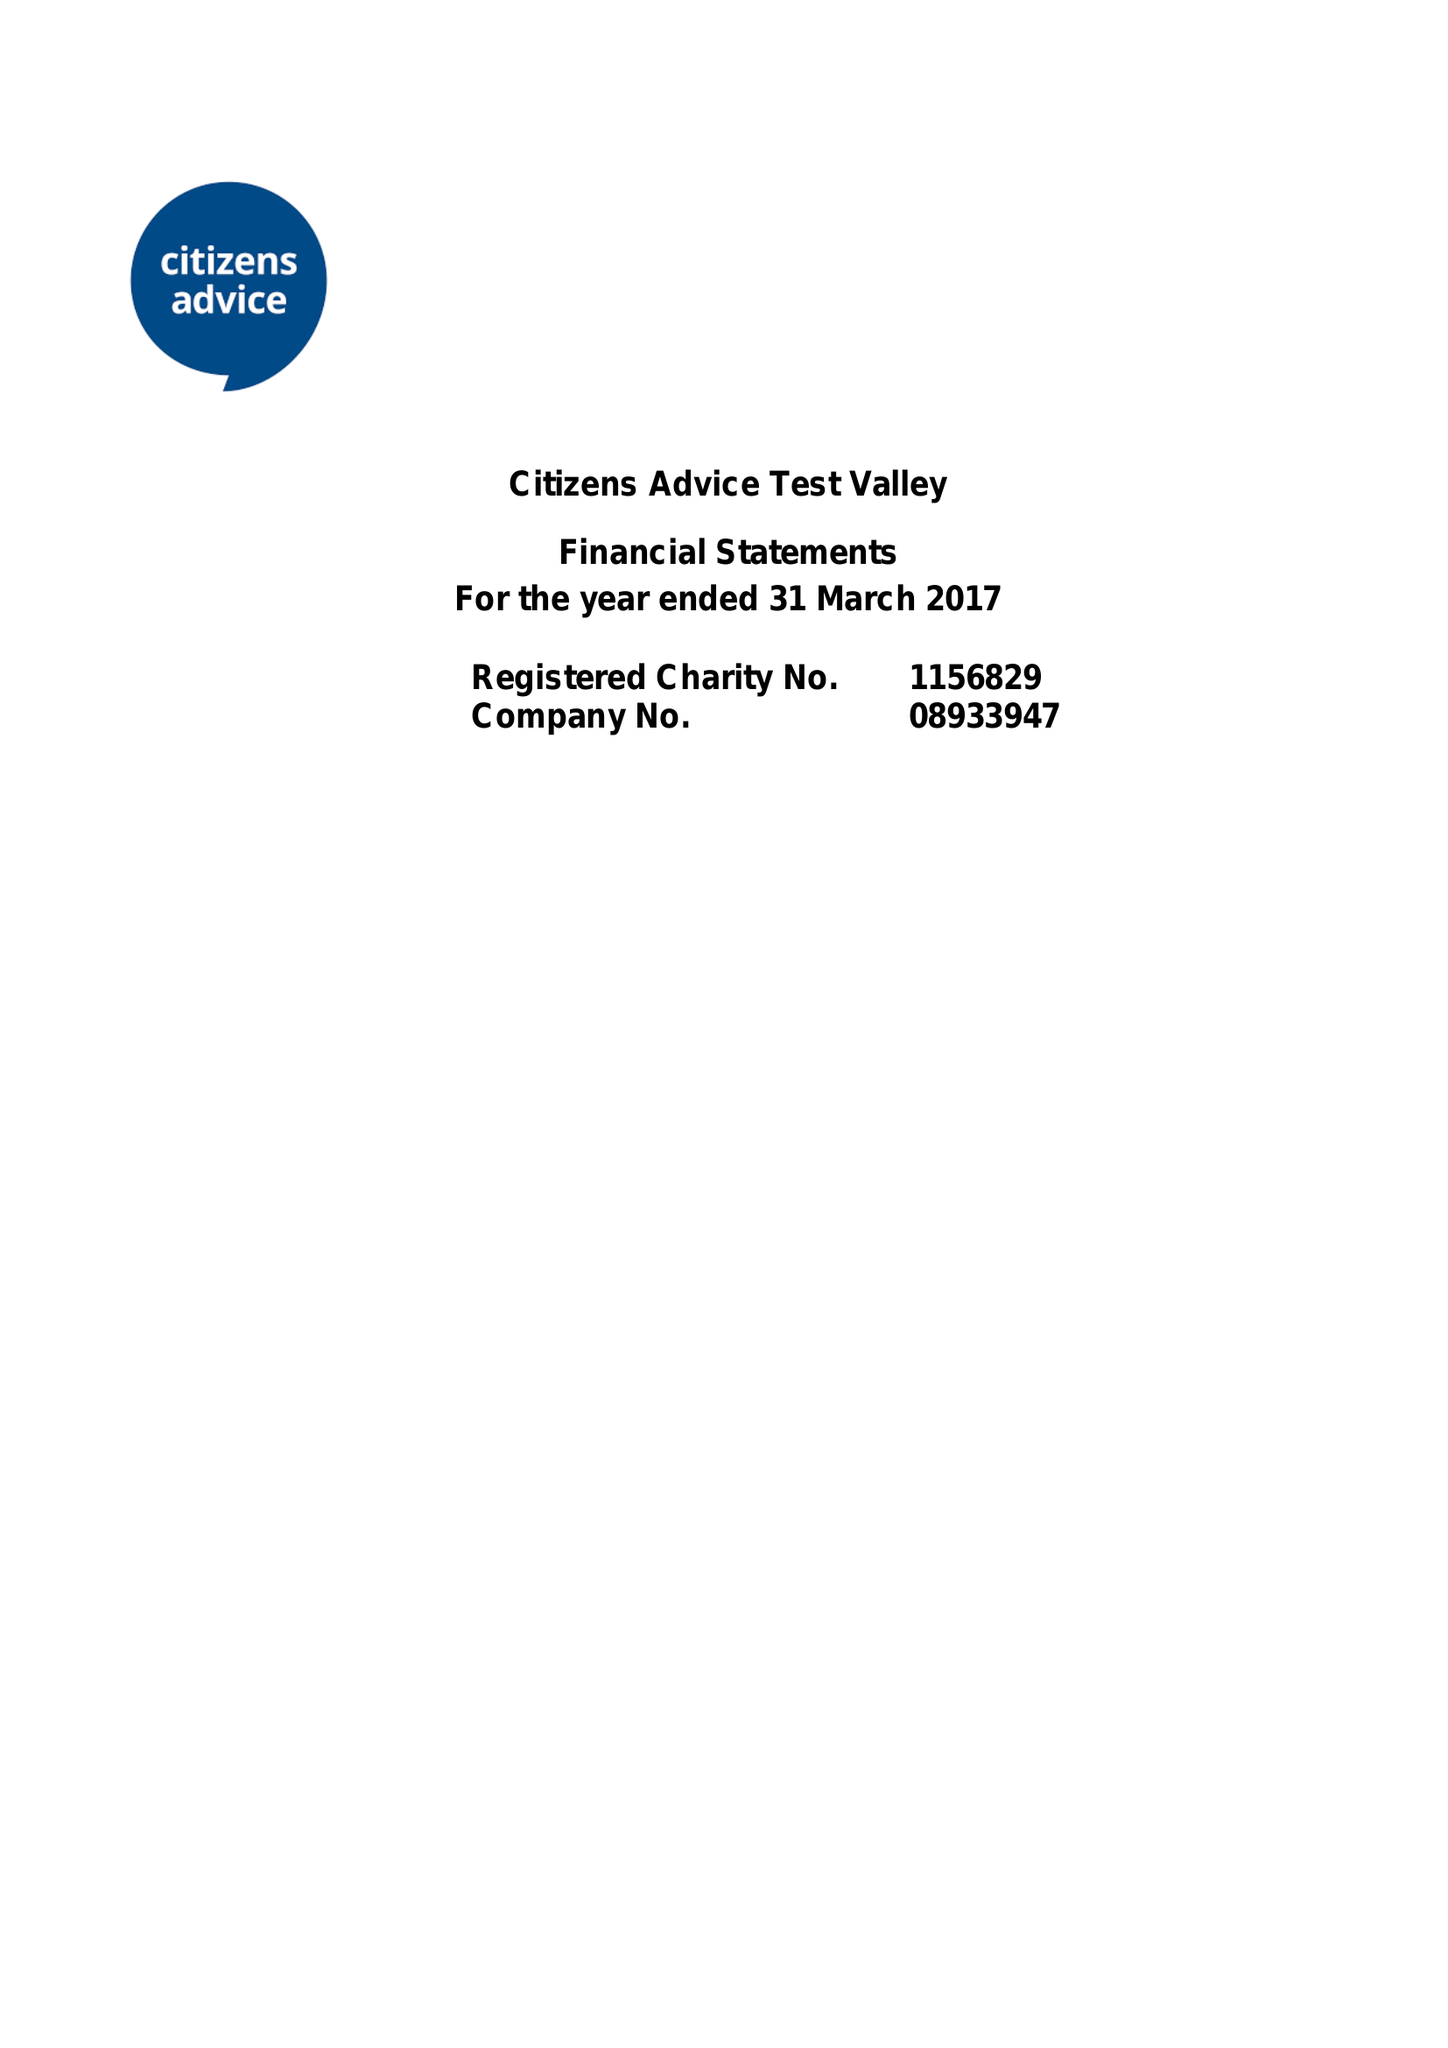What is the value for the report_date?
Answer the question using a single word or phrase. 2017-03-31 